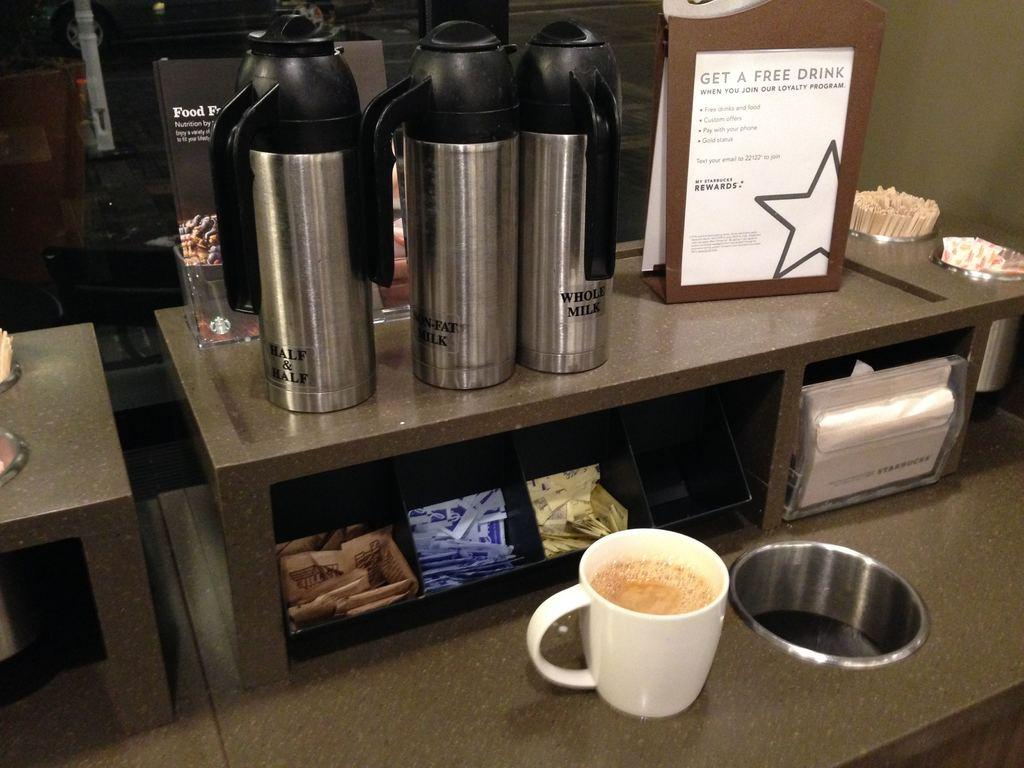Provide a one-sentence caption for the provided image. A sign in a coffee shop advertises the shop's loyalty program. 